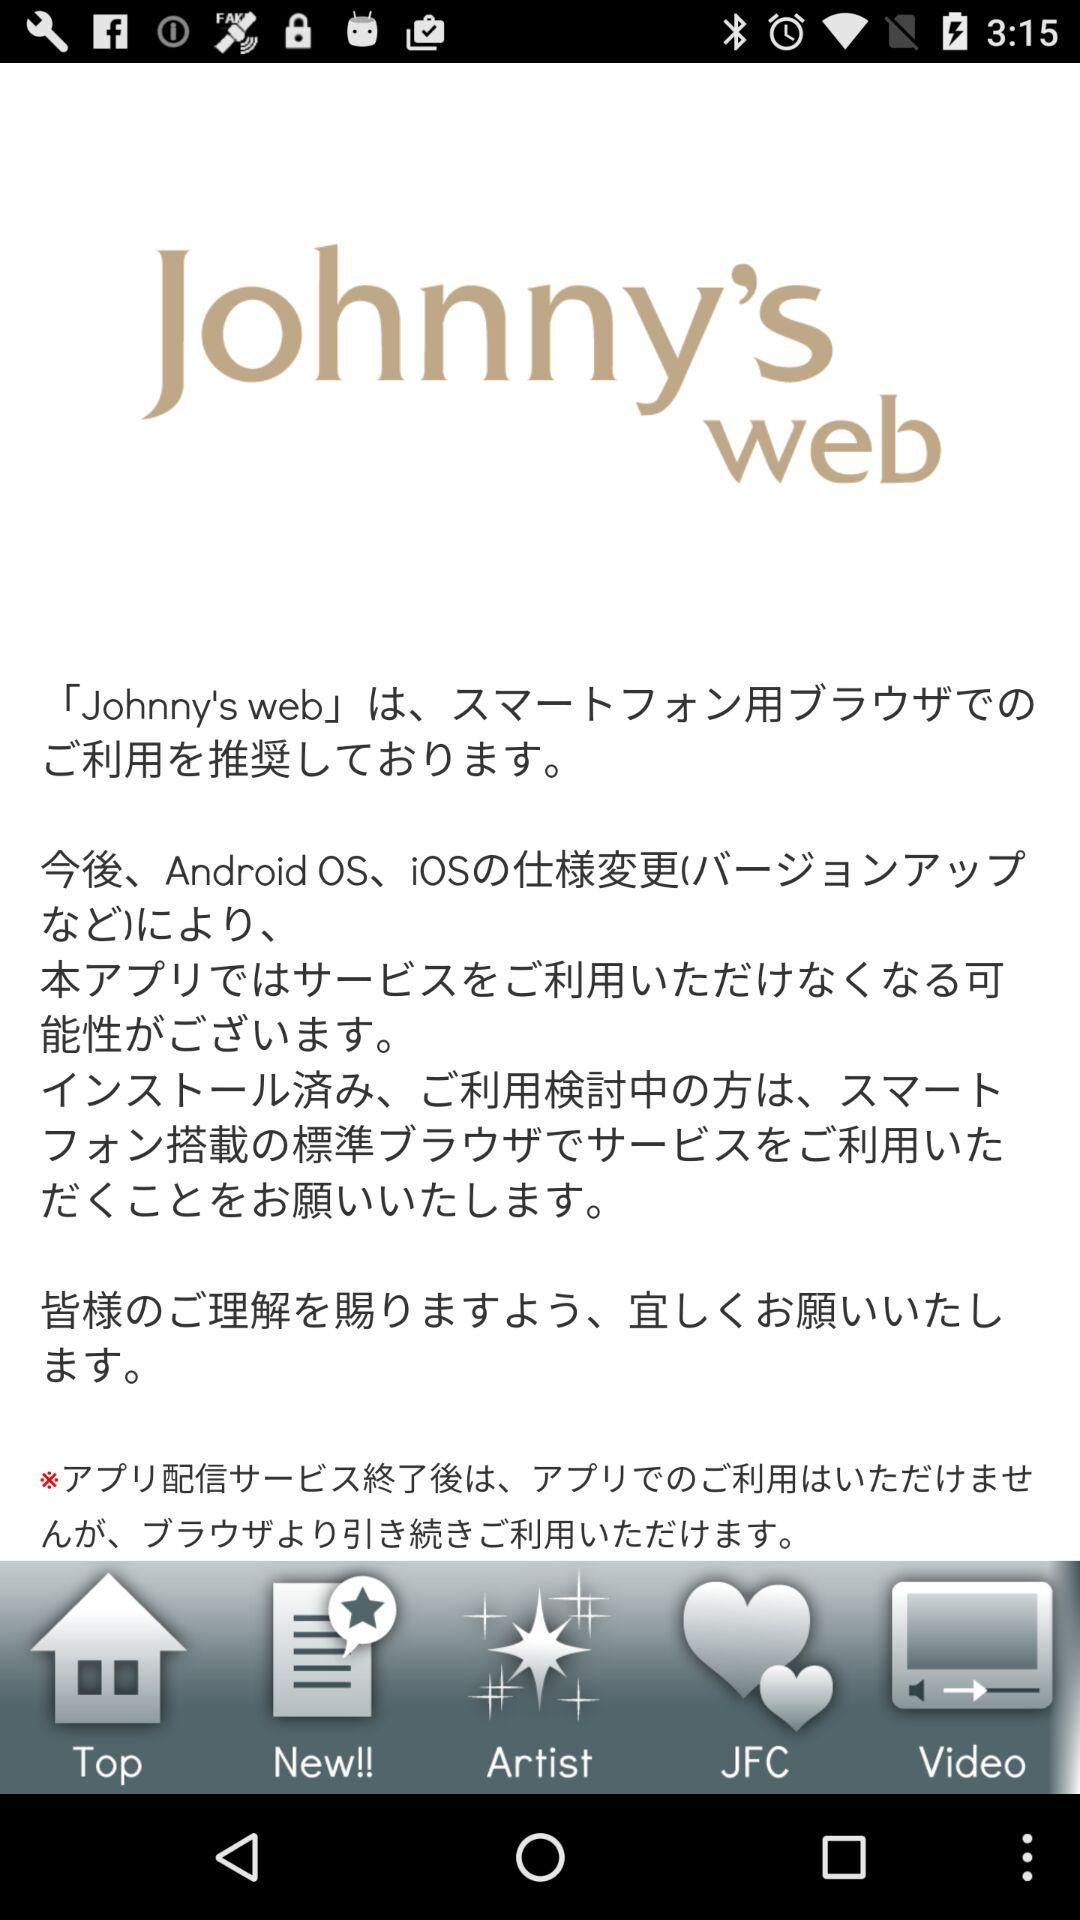What is the name of the application? The name of the application is "Johnny's web". 